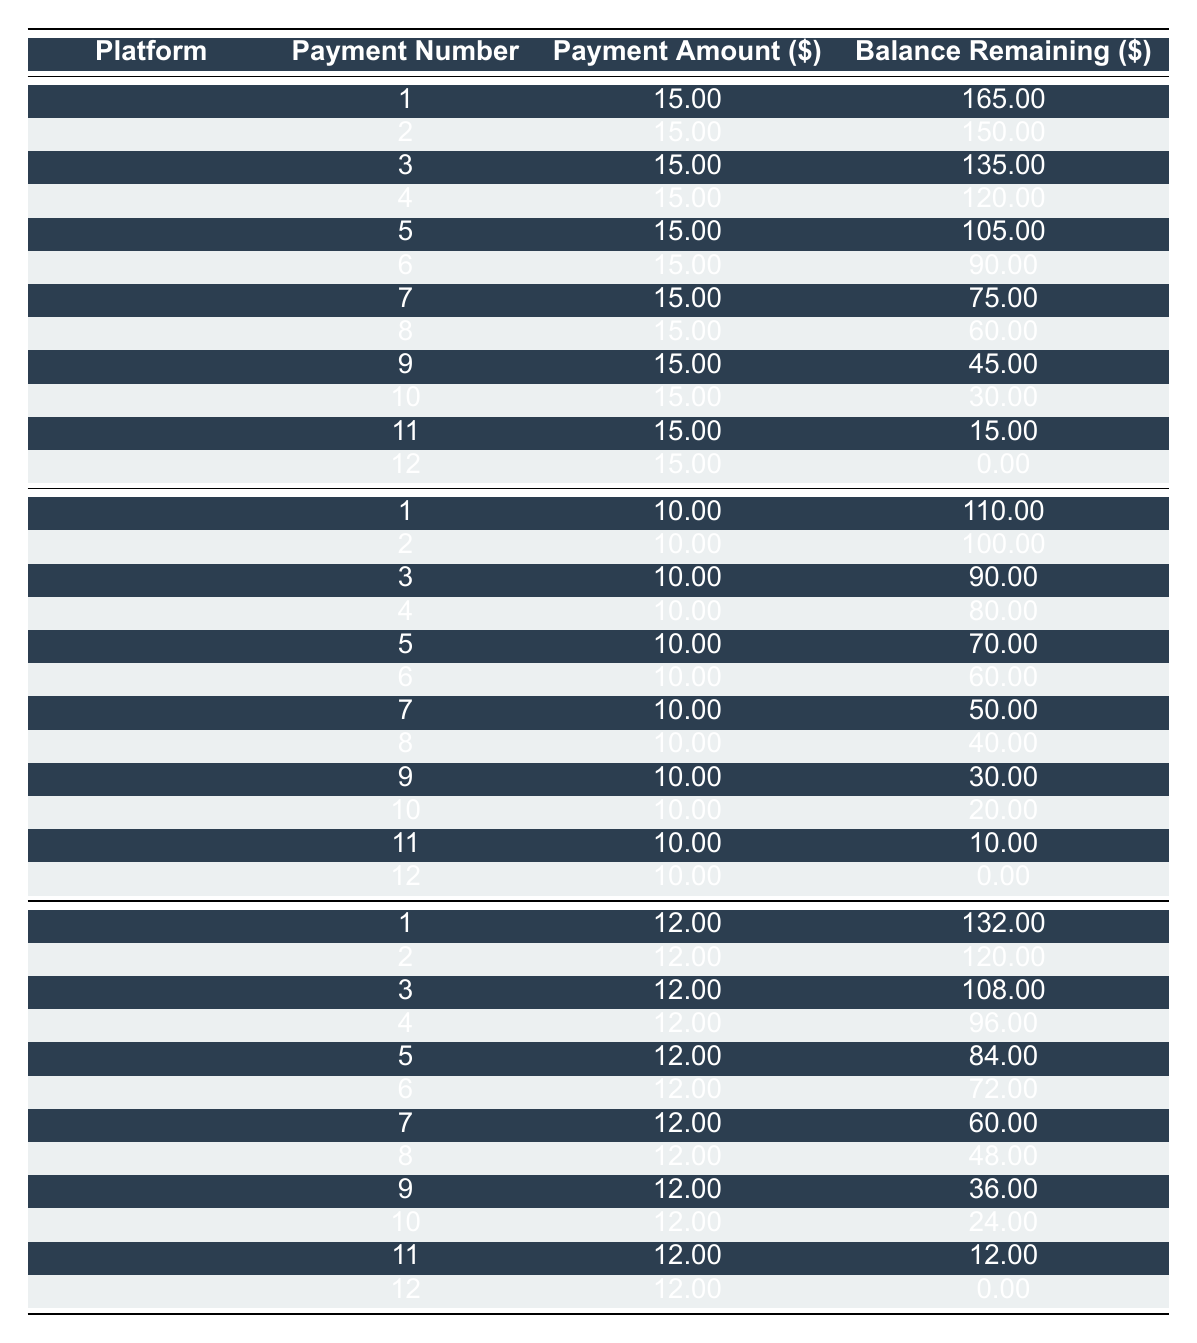What is the monthly fee for a subscription to The New York Times? Refer to the table under The New York Times, the monthly fee is listed as 15.00.
Answer: 15.00 What is the balance remaining after the 5th payment for The Washington Post? The table shows that after the 5th payment, the balance is 70.00.
Answer: 70.00 Is the total payment for The Guardian higher than for The Washington Post? The total payment for The Guardian is 144.00, while for The Washington Post it is 120.00. Since 144.00 is greater than 120.00, this statement is true.
Answer: Yes What is the average monthly fee across all platforms listed? The monthly fees are 15.00 (NYT), 10.00 (WP), and 12.00 (Guardian). To find the average, sum them up: 15.00 + 10.00 + 12.00 = 37.00 and divide by 3, resulting in 37.00 / 3 = 12.33.
Answer: 12.33 How many payments does it take to completely pay off a subscription to The Guardian? The Guardian has a payment schedule of 12 payments, which is indicated in the table.
Answer: 12 payments What is the total balance remaining after the 10th payment for The New York Times? According to the table, the balance remaining after the 10th payment is 30.00.
Answer: 30.00 Is it true that the payment amounts are the same for each month for The Washington Post? Yes, each month's payment amount is consistently 10.00, as shown in the payment schedule.
Answer: Yes Which platform has the highest monthly fee and what is that fee? By comparing the monthly fees, The New York Times has the highest fee at 15.00.
Answer: 15.00 How much less is the total initial payment for The Washington Post compared to The Guardian? The initial payment for The Washington Post is 120.00 and for The Guardian, it is 144.00. The difference is 144.00 - 120.00 = 24.00.
Answer: 24.00 